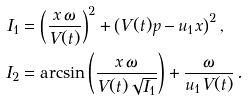Convert formula to latex. <formula><loc_0><loc_0><loc_500><loc_500>I _ { 1 } & = \left ( \frac { x \, \omega } { V ( t ) } \right ) ^ { 2 } + \left ( V ( t ) p - u _ { 1 } x \right ) ^ { 2 } , \\ I _ { 2 } & = \arcsin \left ( \frac { x \, \omega } { V ( t ) \sqrt { I _ { 1 } } } \right ) + \frac { \omega } { u _ { 1 } V ( t ) } \, .</formula> 